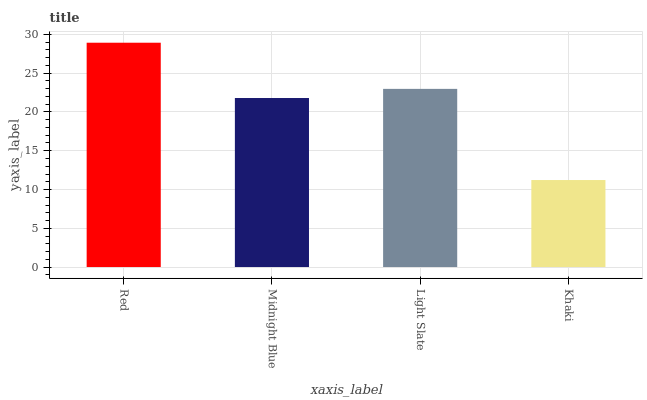Is Khaki the minimum?
Answer yes or no. Yes. Is Red the maximum?
Answer yes or no. Yes. Is Midnight Blue the minimum?
Answer yes or no. No. Is Midnight Blue the maximum?
Answer yes or no. No. Is Red greater than Midnight Blue?
Answer yes or no. Yes. Is Midnight Blue less than Red?
Answer yes or no. Yes. Is Midnight Blue greater than Red?
Answer yes or no. No. Is Red less than Midnight Blue?
Answer yes or no. No. Is Light Slate the high median?
Answer yes or no. Yes. Is Midnight Blue the low median?
Answer yes or no. Yes. Is Red the high median?
Answer yes or no. No. Is Light Slate the low median?
Answer yes or no. No. 